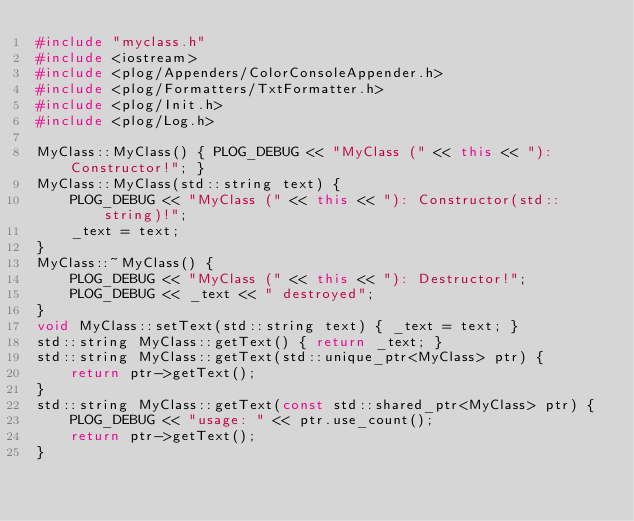Convert code to text. <code><loc_0><loc_0><loc_500><loc_500><_C++_>#include "myclass.h"
#include <iostream>
#include <plog/Appenders/ColorConsoleAppender.h>
#include <plog/Formatters/TxtFormatter.h>
#include <plog/Init.h>
#include <plog/Log.h>

MyClass::MyClass() { PLOG_DEBUG << "MyClass (" << this << "): Constructor!"; }
MyClass::MyClass(std::string text) {
    PLOG_DEBUG << "MyClass (" << this << "): Constructor(std::string)!";
    _text = text;
}
MyClass::~MyClass() {
    PLOG_DEBUG << "MyClass (" << this << "): Destructor!";
    PLOG_DEBUG << _text << " destroyed";
}
void MyClass::setText(std::string text) { _text = text; }
std::string MyClass::getText() { return _text; }
std::string MyClass::getText(std::unique_ptr<MyClass> ptr) {
    return ptr->getText();
}
std::string MyClass::getText(const std::shared_ptr<MyClass> ptr) {
    PLOG_DEBUG << "usage: " << ptr.use_count();
    return ptr->getText();
}</code> 